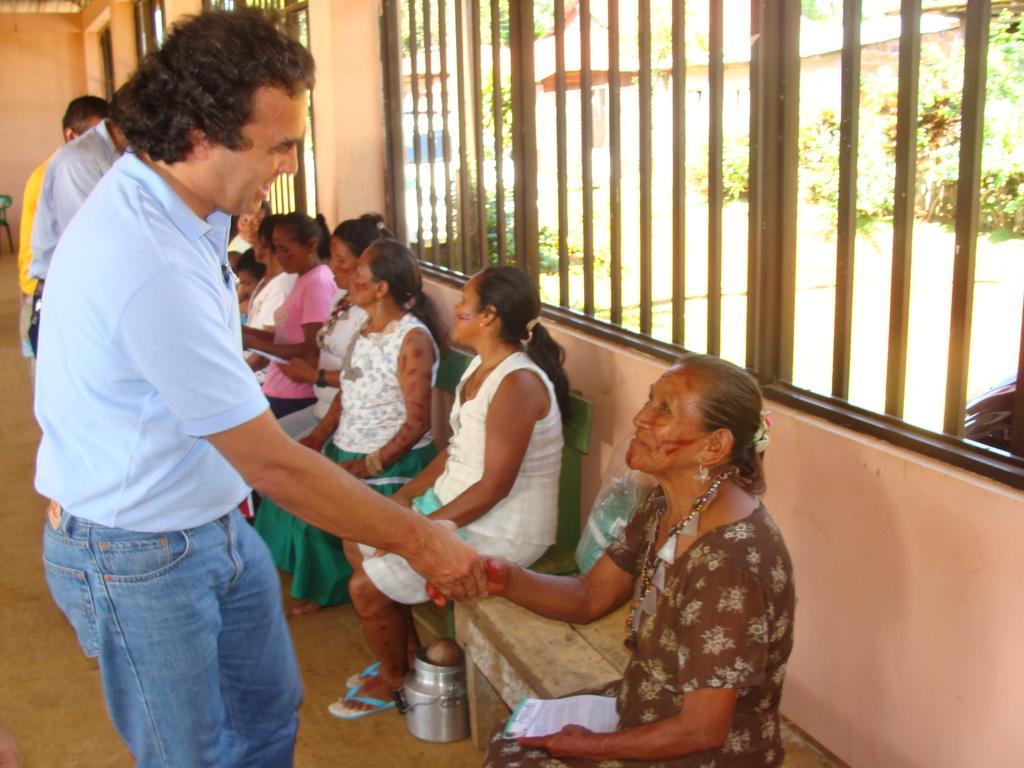How would you summarize this image in a sentence or two? In this image we can see a few people, among them some people are standing and some people are sitting on the benches, behind them, we can see the windows, from the windows we can see some plants and also we can see a chair and a can on the floor. 